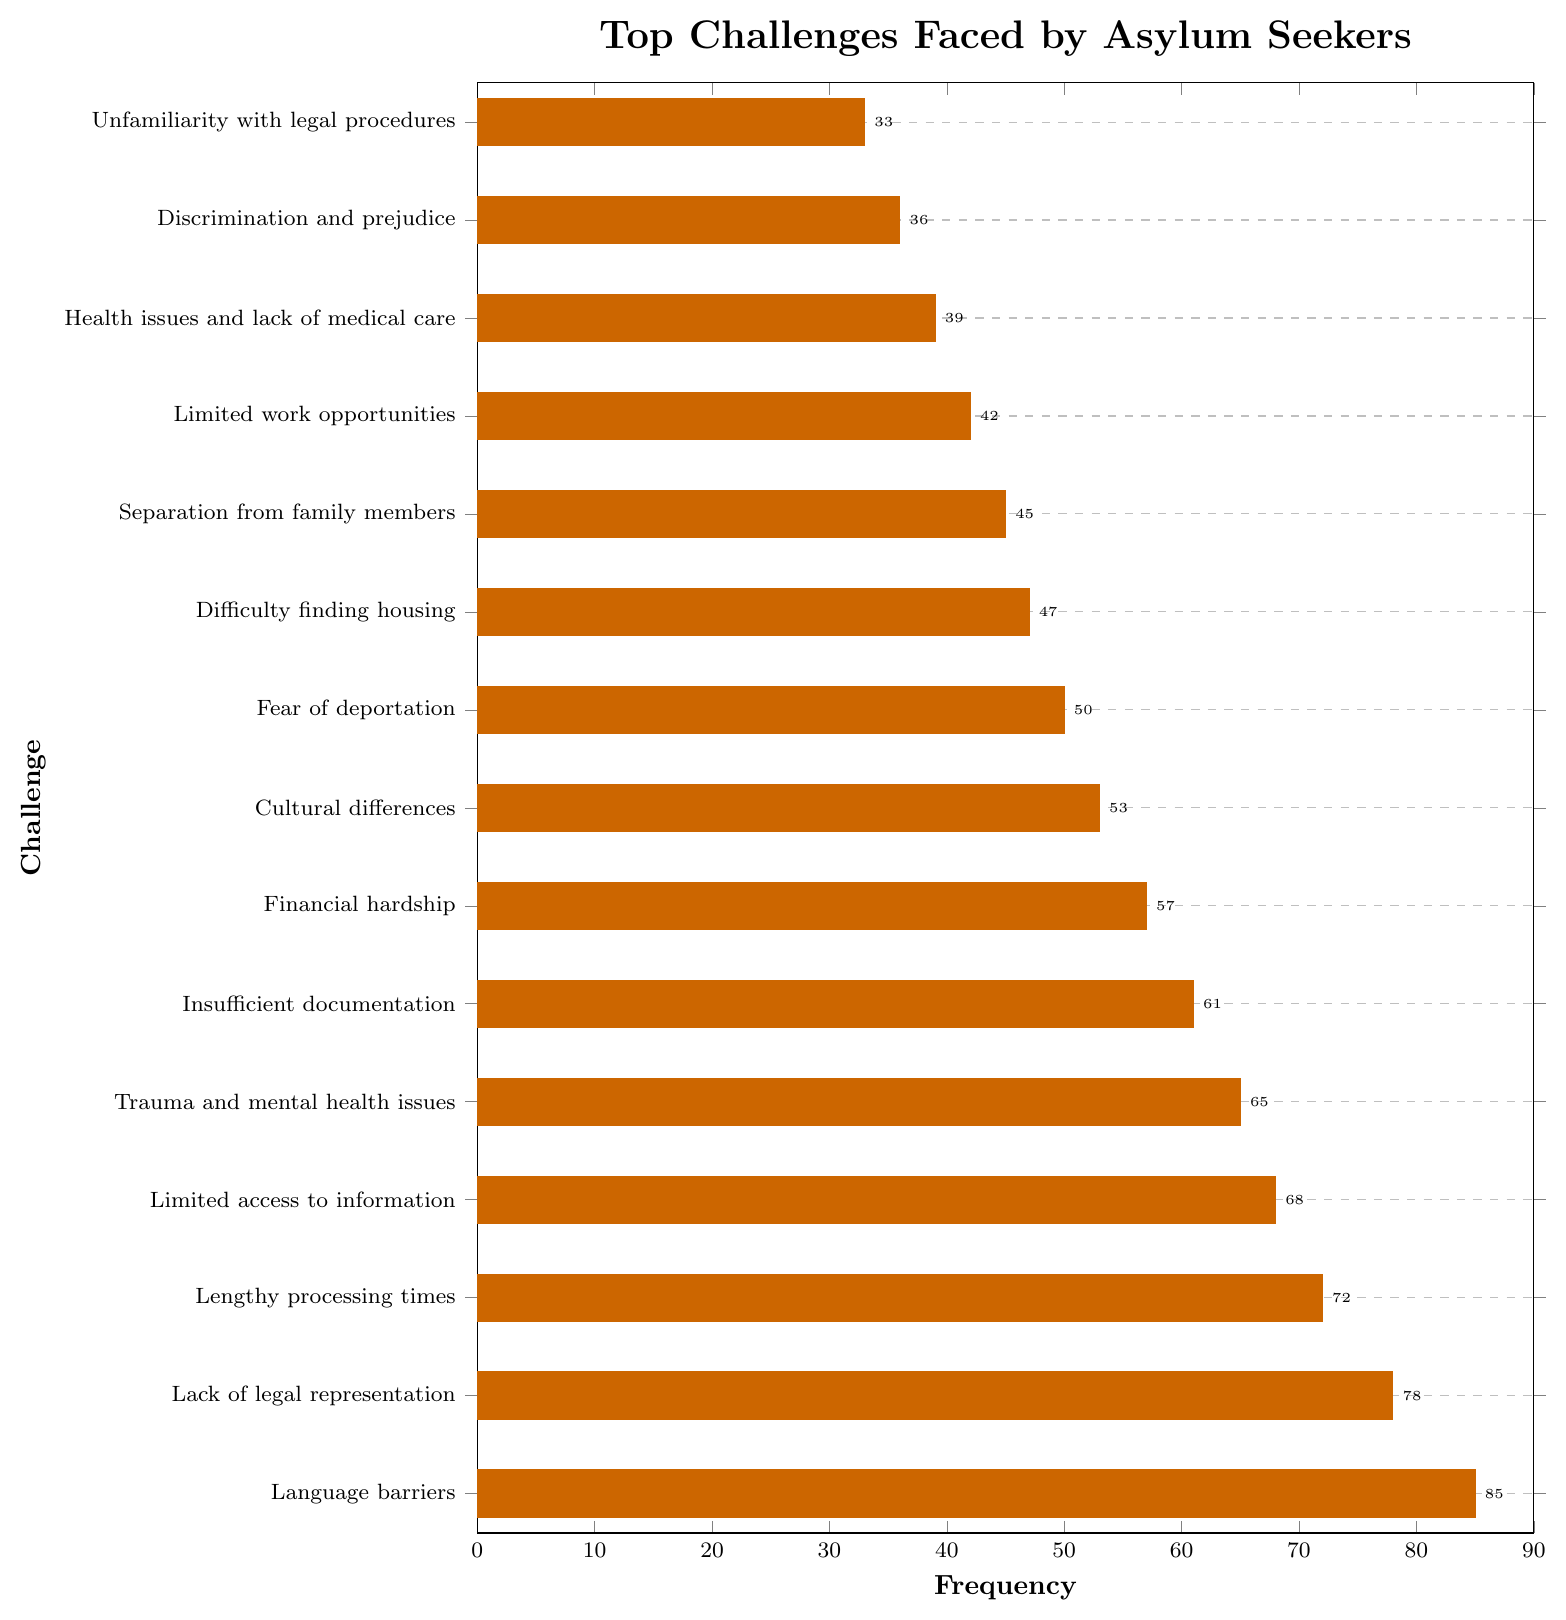What is the most frequent challenge faced by asylum seekers during the application process? The most frequent challenge is the one with the highest bar in the bar chart. Based on the data, the highest bar corresponds to "Language barriers" with a frequency of 85.
Answer: Language barriers Which challenge is faced by asylum seekers less frequently: "Trauma and mental health issues" or "Financial hardship"? To determine this, compare the frequencies of the two challenges. "Trauma and mental health issues" has a frequency of 65, while "Financial hardship" has a frequency of 57. Thus, "Financial hardship" is faced less frequently.
Answer: Financial hardship How many more asylum seekers face "Lack of legal representation" compared to those facing "Separation from family members"? "Lack of legal representation" has a frequency of 78, and "Separation from family members" has a frequency of 45. Calculate the difference: 78 - 45 = 33.
Answer: 33 What is the combined frequency of the three least frequent challenges? The three least frequent challenges are "Unfamiliarity with legal procedures" (33), "Discrimination and prejudice" (36), and "Health issues and lack of medical care" (39). Calculate the sum: 33 + 36 + 39 = 108.
Answer: 108 Which two consecutive challenges have the smallest difference in their frequencies? Look at the frequencies and find the two consecutive values with the smallest difference. "Limited access to information" (68) and "Trauma and mental health issues" (65) have a difference of 3, which is the smallest.
Answer: Limited access to information and Trauma and mental health issues What is the median frequency of the challenges listed? To find the median, first list the frequencies in ascending order: 33, 36, 39, 42, 45, 47, 50, 53, 57, 61, 65, 68, 72, 78, 85. The median is the middle value, which is the 8th value in this ordered list, 53.
Answer: 53 Are there any challenges with the same frequency? By examining the bar chart, we can see that each challenge has a distinct frequency value. Therefore, no challenges have the same frequency.
Answer: No What percentage of the total challenges faced does the "Lengthy processing times" represent? First, find the total frequency by summing all the frequencies: 33 + 36 + 39 + 42 + 45 + 47 + 50 + 53 + 57 + 61 + 65 + 68 + 72 + 78 + 85 = 831. Then find the percentage: (72 / 831) * 100 ≈ 8.66%.
Answer: 8.66% How many more asylum seekers face "Difficulty finding housing" than face "Limited work opportunities"? "Difficulty finding housing" has a frequency of 47, and "Limited work opportunities" has a frequency of 42. Calculate the difference: 47 - 42 = 5.
Answer: 5 